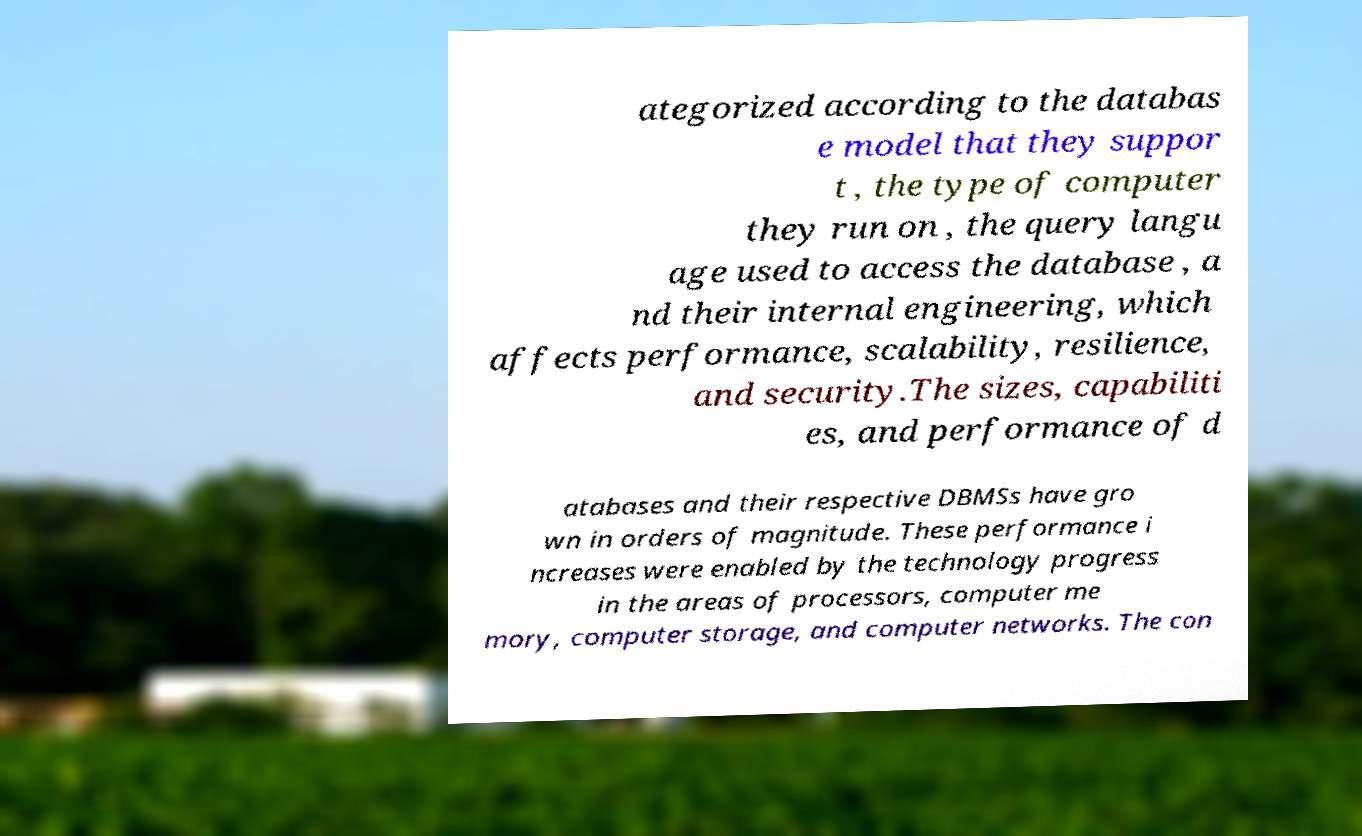Please identify and transcribe the text found in this image. ategorized according to the databas e model that they suppor t , the type of computer they run on , the query langu age used to access the database , a nd their internal engineering, which affects performance, scalability, resilience, and security.The sizes, capabiliti es, and performance of d atabases and their respective DBMSs have gro wn in orders of magnitude. These performance i ncreases were enabled by the technology progress in the areas of processors, computer me mory, computer storage, and computer networks. The con 